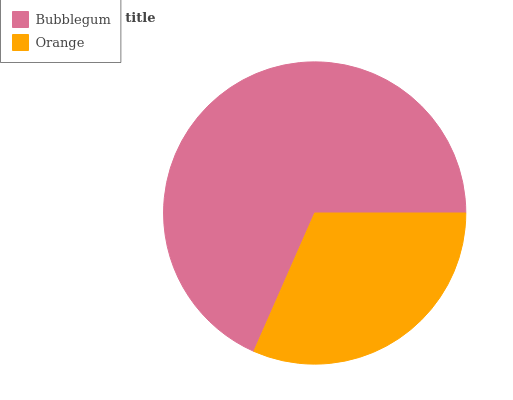Is Orange the minimum?
Answer yes or no. Yes. Is Bubblegum the maximum?
Answer yes or no. Yes. Is Orange the maximum?
Answer yes or no. No. Is Bubblegum greater than Orange?
Answer yes or no. Yes. Is Orange less than Bubblegum?
Answer yes or no. Yes. Is Orange greater than Bubblegum?
Answer yes or no. No. Is Bubblegum less than Orange?
Answer yes or no. No. Is Bubblegum the high median?
Answer yes or no. Yes. Is Orange the low median?
Answer yes or no. Yes. Is Orange the high median?
Answer yes or no. No. Is Bubblegum the low median?
Answer yes or no. No. 